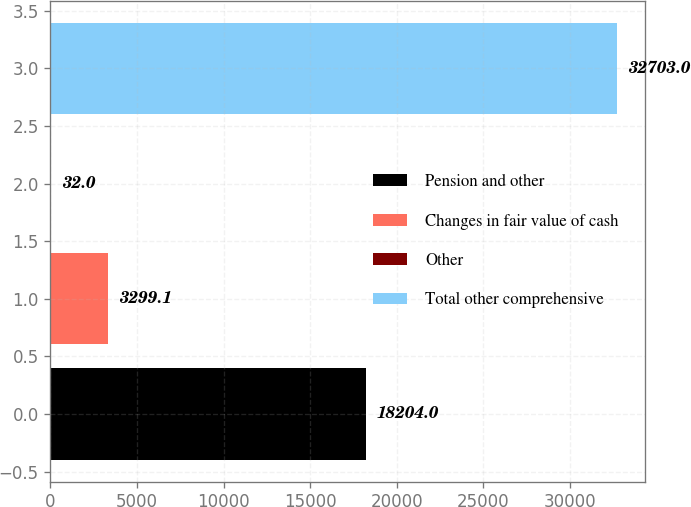Convert chart to OTSL. <chart><loc_0><loc_0><loc_500><loc_500><bar_chart><fcel>Pension and other<fcel>Changes in fair value of cash<fcel>Other<fcel>Total other comprehensive<nl><fcel>18204<fcel>3299.1<fcel>32<fcel>32703<nl></chart> 